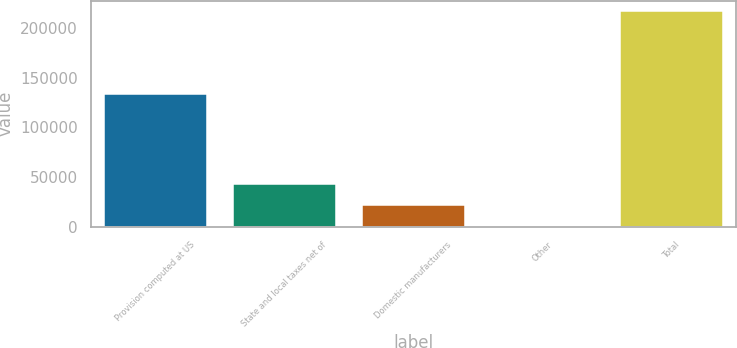Convert chart. <chart><loc_0><loc_0><loc_500><loc_500><bar_chart><fcel>Provision computed at US<fcel>State and local taxes net of<fcel>Domestic manufacturers<fcel>Other<fcel>Total<nl><fcel>133196<fcel>43453.4<fcel>21792.7<fcel>132<fcel>216739<nl></chart> 